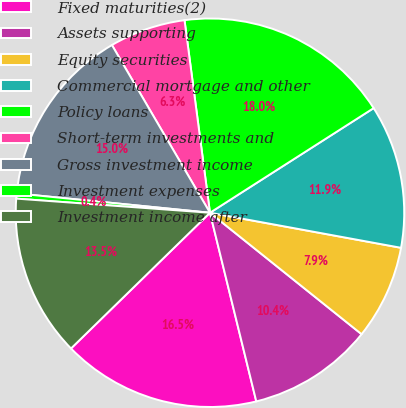<chart> <loc_0><loc_0><loc_500><loc_500><pie_chart><fcel>Fixed maturities(2)<fcel>Assets supporting<fcel>Equity securities<fcel>Commercial mortgage and other<fcel>Policy loans<fcel>Short-term investments and<fcel>Gross investment income<fcel>Investment expenses<fcel>Investment income after<nl><fcel>16.52%<fcel>10.42%<fcel>7.86%<fcel>11.94%<fcel>18.04%<fcel>6.33%<fcel>14.99%<fcel>0.43%<fcel>13.47%<nl></chart> 